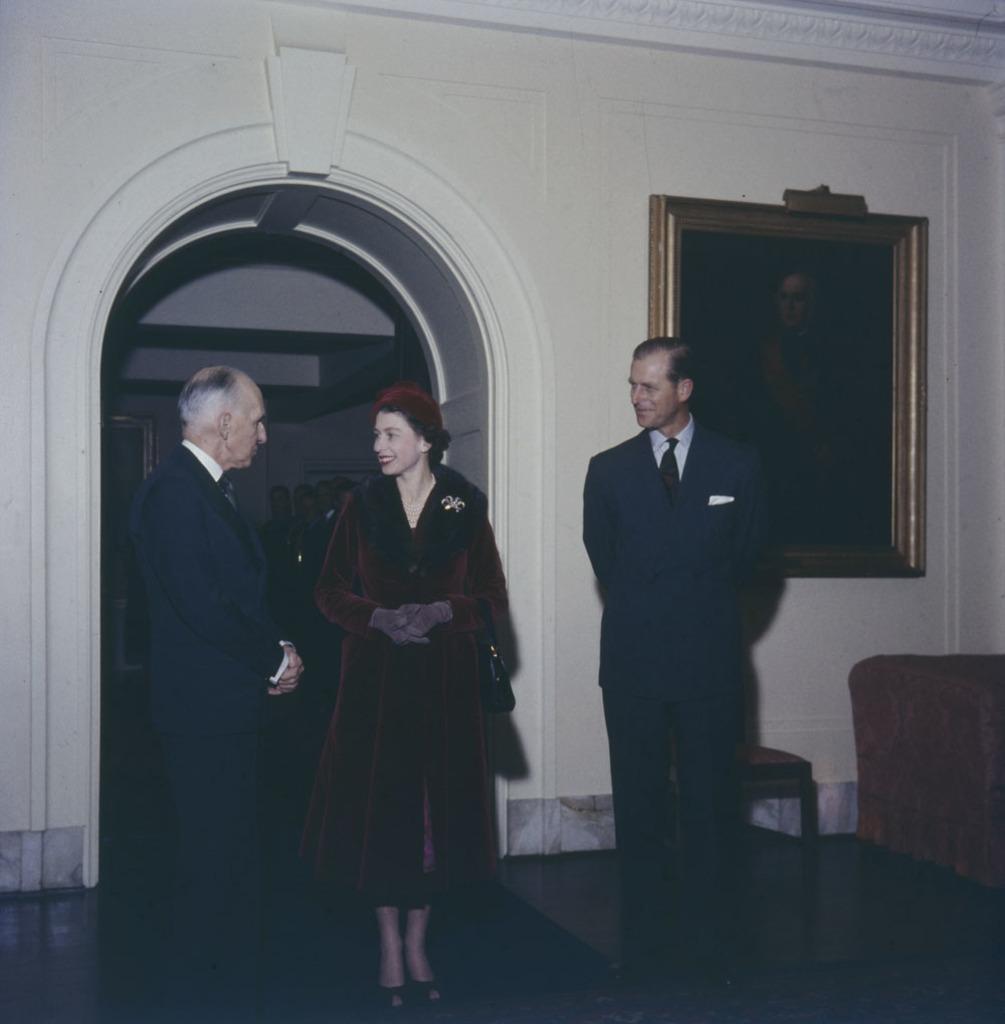Describe this image in one or two sentences. In this image I can see there are two men and a woman standing and speaking. There are a few more people standing in the backdrop. There is a photo frame attached to the wall, there is a couch and a chair at the right side. 